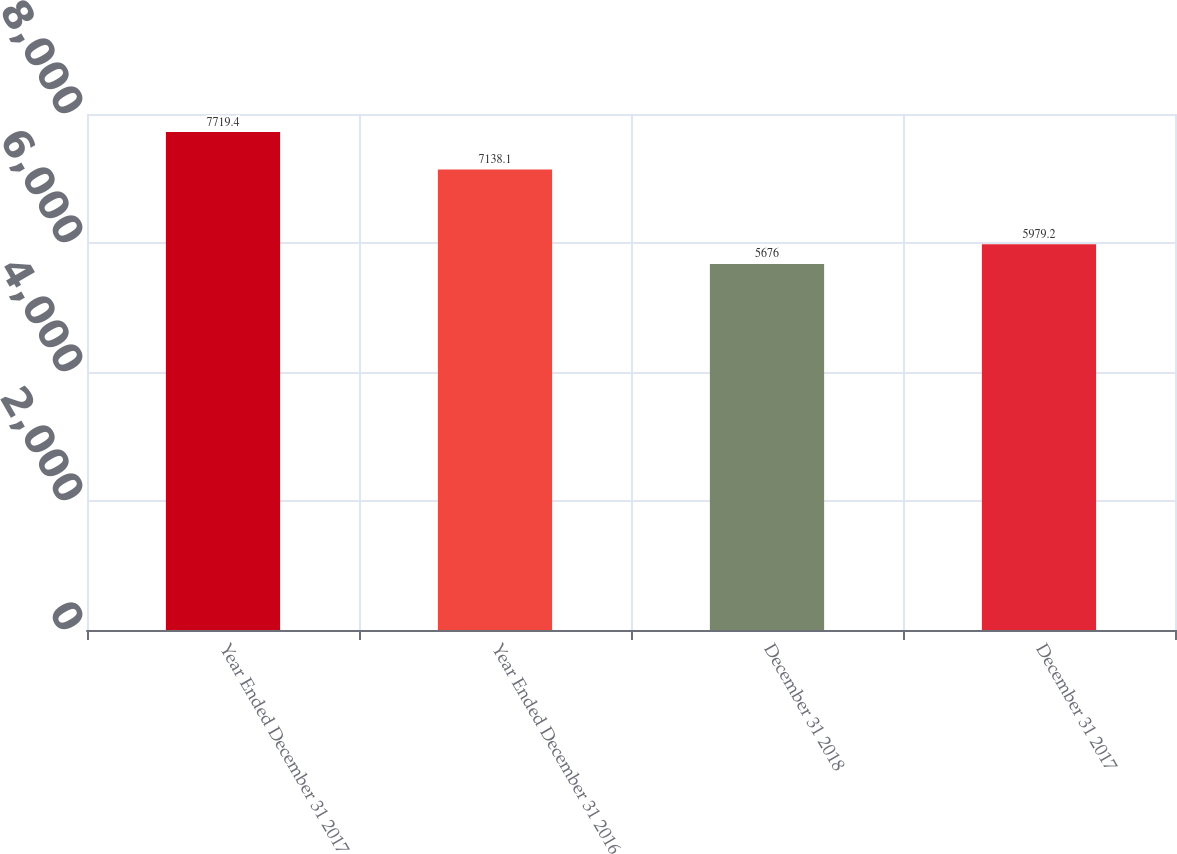Convert chart. <chart><loc_0><loc_0><loc_500><loc_500><bar_chart><fcel>Year Ended December 31 2017<fcel>Year Ended December 31 2016<fcel>December 31 2018<fcel>December 31 2017<nl><fcel>7719.4<fcel>7138.1<fcel>5676<fcel>5979.2<nl></chart> 